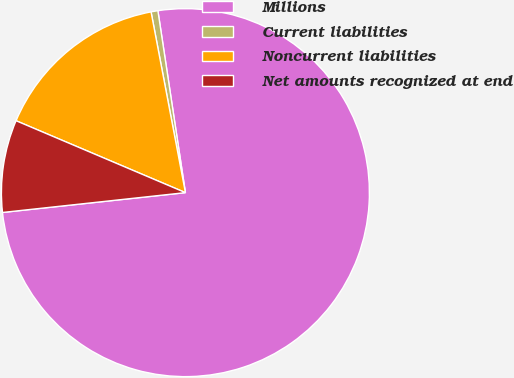<chart> <loc_0><loc_0><loc_500><loc_500><pie_chart><fcel>Millions<fcel>Current liabilities<fcel>Noncurrent liabilities<fcel>Net amounts recognized at end<nl><fcel>75.67%<fcel>0.6%<fcel>15.62%<fcel>8.11%<nl></chart> 